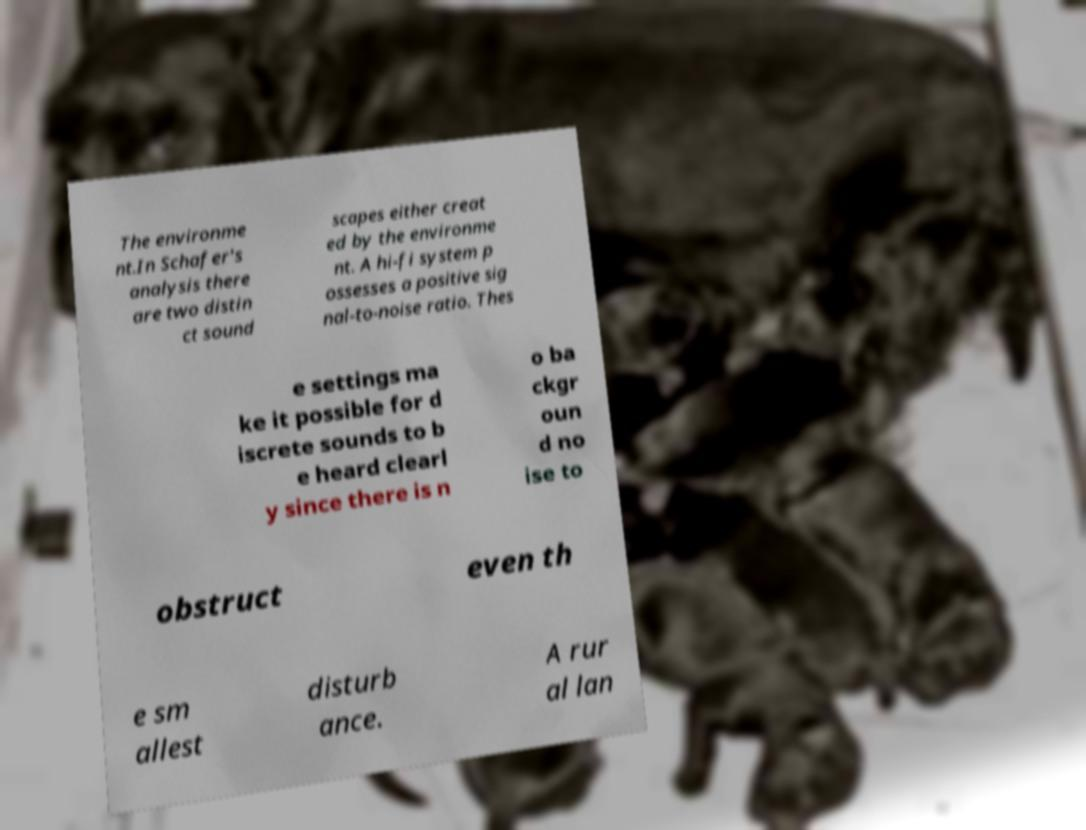What messages or text are displayed in this image? I need them in a readable, typed format. The environme nt.In Schafer's analysis there are two distin ct sound scapes either creat ed by the environme nt. A hi-fi system p ossesses a positive sig nal-to-noise ratio. Thes e settings ma ke it possible for d iscrete sounds to b e heard clearl y since there is n o ba ckgr oun d no ise to obstruct even th e sm allest disturb ance. A rur al lan 